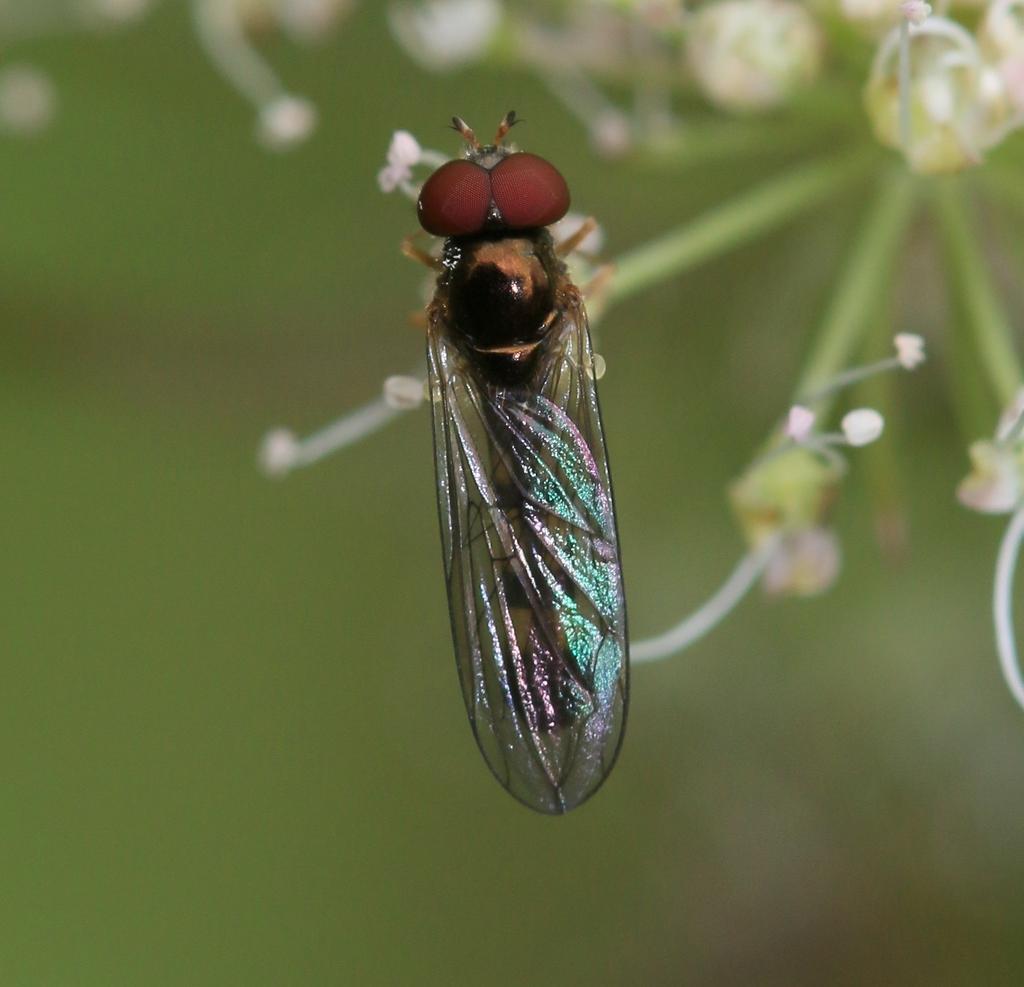Please provide a concise description of this image. In this picture we can see an insect, flowers and in the background we can see it is blurry. 